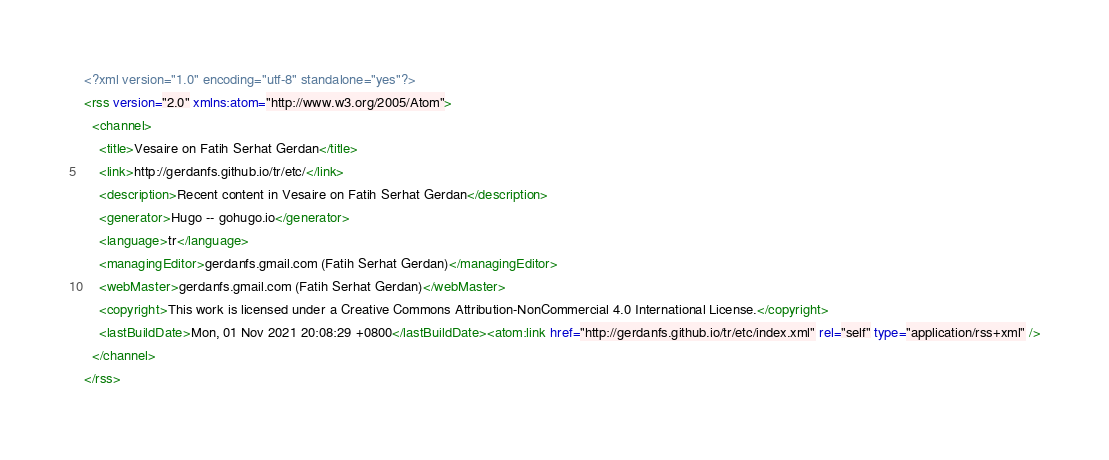Convert code to text. <code><loc_0><loc_0><loc_500><loc_500><_XML_><?xml version="1.0" encoding="utf-8" standalone="yes"?>
<rss version="2.0" xmlns:atom="http://www.w3.org/2005/Atom">
  <channel>
    <title>Vesaire on Fatih Serhat Gerdan</title>
    <link>http://gerdanfs.github.io/tr/etc/</link>
    <description>Recent content in Vesaire on Fatih Serhat Gerdan</description>
    <generator>Hugo -- gohugo.io</generator>
    <language>tr</language>
    <managingEditor>gerdanfs.gmail.com (Fatih Serhat Gerdan)</managingEditor>
    <webMaster>gerdanfs.gmail.com (Fatih Serhat Gerdan)</webMaster>
    <copyright>This work is licensed under a Creative Commons Attribution-NonCommercial 4.0 International License.</copyright>
    <lastBuildDate>Mon, 01 Nov 2021 20:08:29 +0800</lastBuildDate><atom:link href="http://gerdanfs.github.io/tr/etc/index.xml" rel="self" type="application/rss+xml" />
  </channel>
</rss>
</code> 